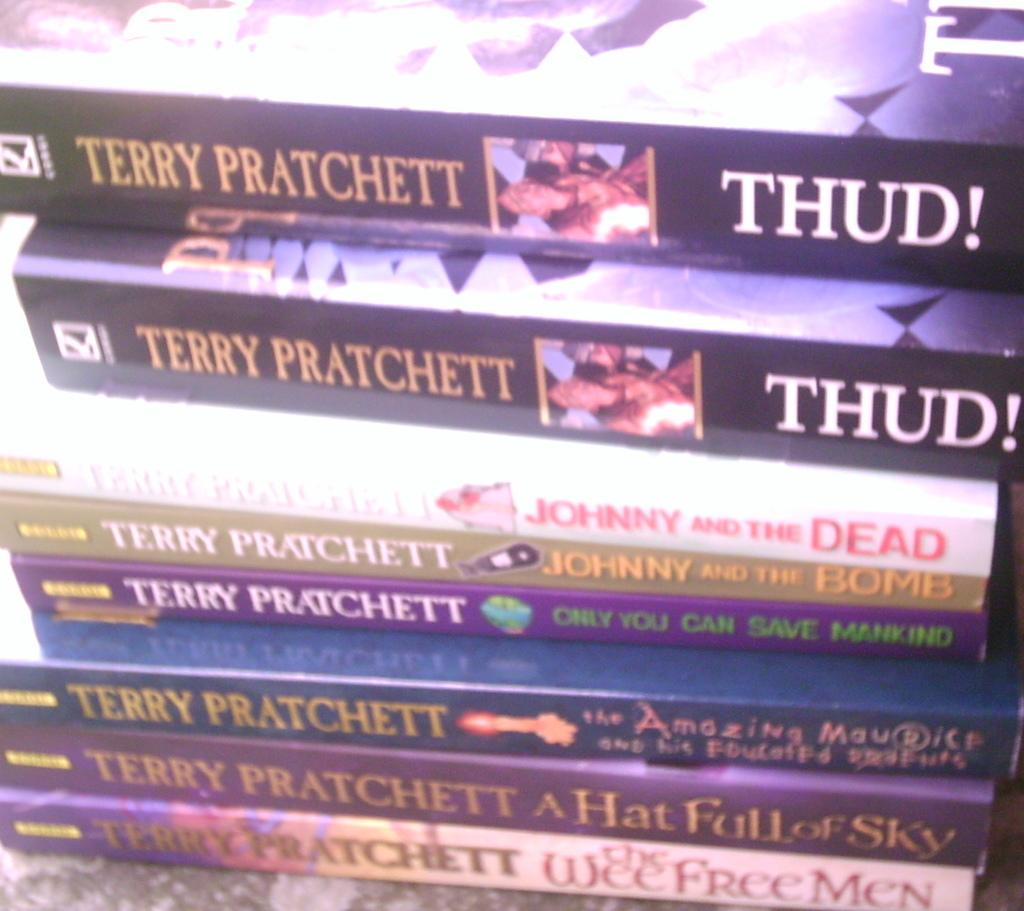<image>
Offer a succinct explanation of the picture presented. Terry Pratchett Thud, Johnny and the dead. Johny and the bomb, Only you can save mankind, and A hat full of sky collection. 